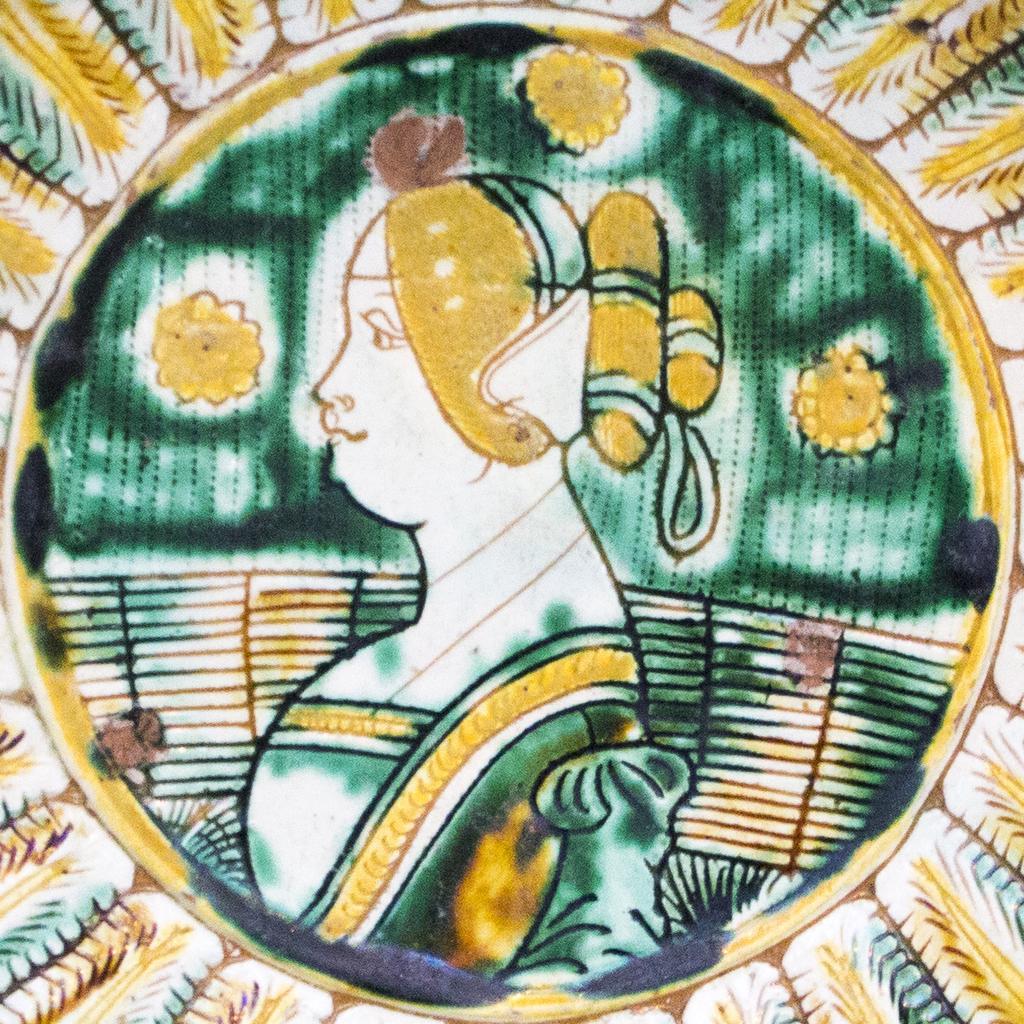In one or two sentences, can you explain what this image depicts? This is a drawing of a woman. 